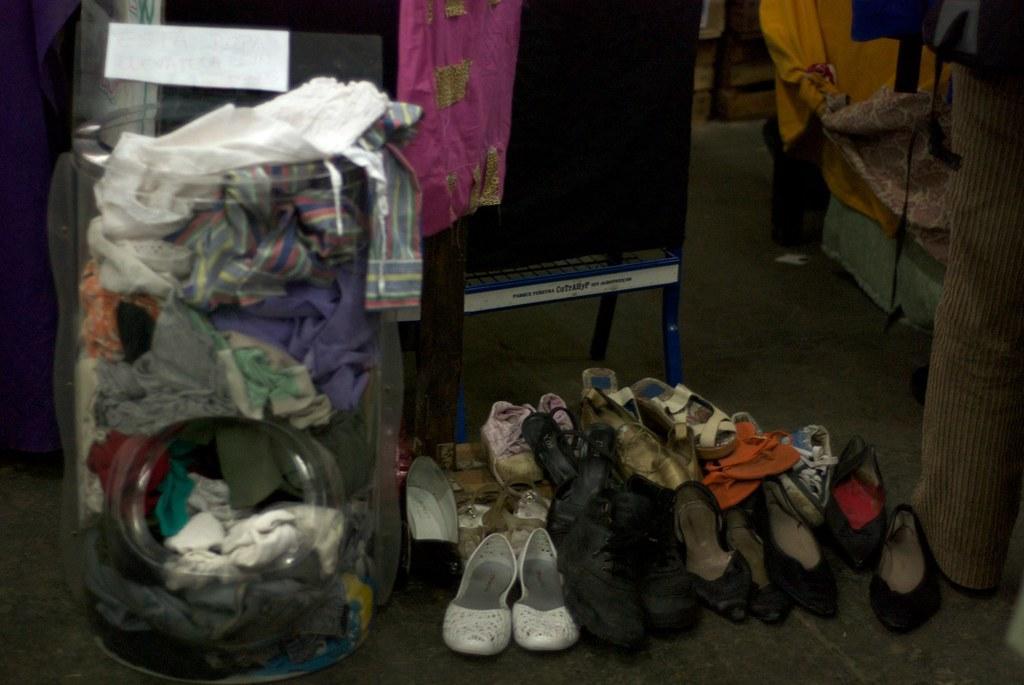How would you summarize this image in a sentence or two? In this image I can see a tub, on the tub I can see a clothes and I can see shoes and chair visible on the floor. 